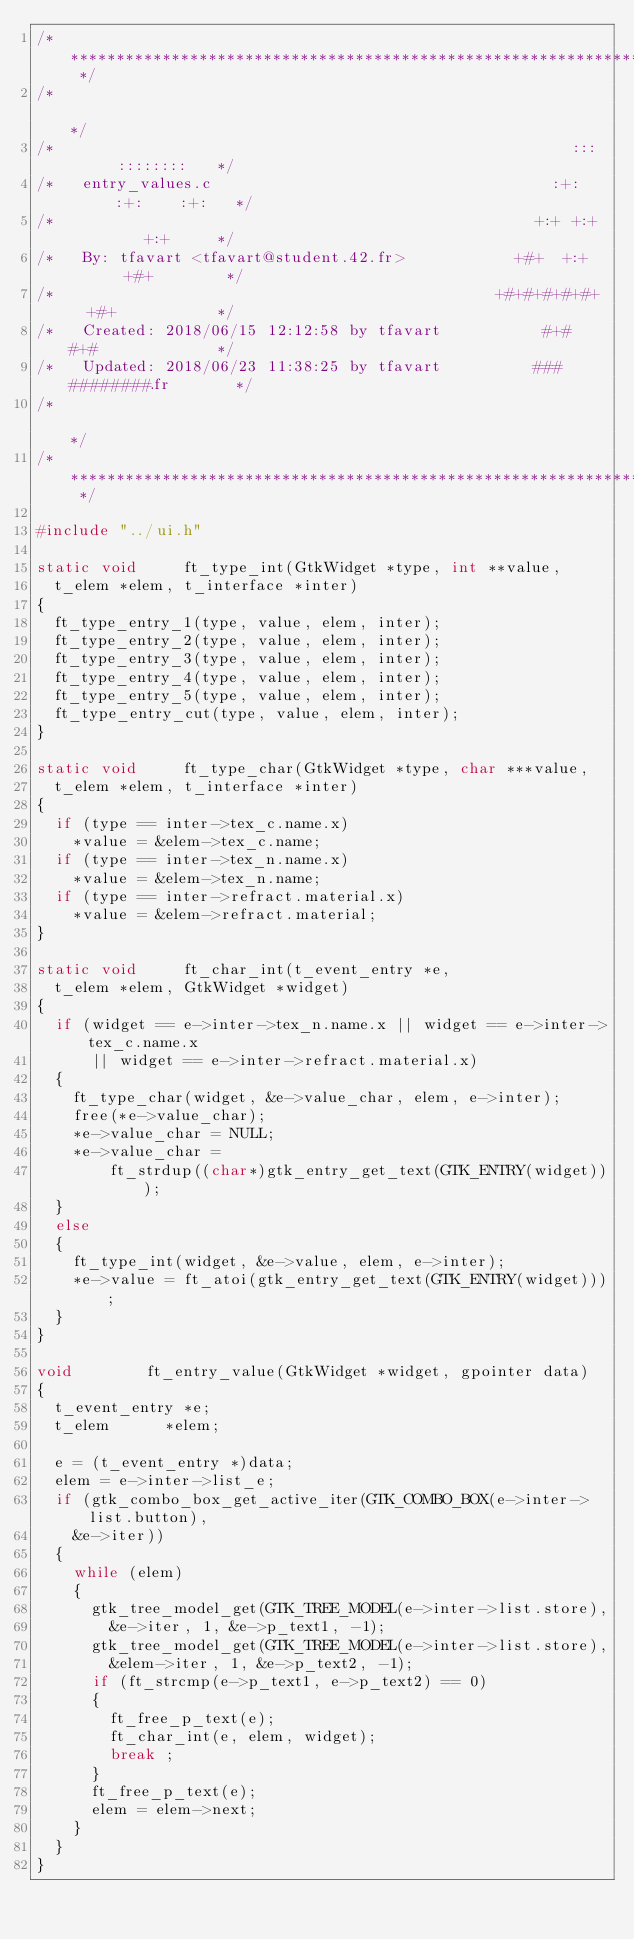<code> <loc_0><loc_0><loc_500><loc_500><_C_>/* ************************************************************************** */
/*                                                                            */
/*                                                        :::      ::::::::   */
/*   entry_values.c                                     :+:      :+:    :+:   */
/*                                                    +:+ +:+         +:+     */
/*   By: tfavart <tfavart@student.42.fr>            +#+  +:+       +#+        */
/*                                                +#+#+#+#+#+   +#+           */
/*   Created: 2018/06/15 12:12:58 by tfavart           #+#    #+#             */
/*   Updated: 2018/06/23 11:38:25 by tfavart          ###   ########.fr       */
/*                                                                            */
/* ************************************************************************** */

#include "../ui.h"

static void			ft_type_int(GtkWidget *type, int **value,
	t_elem *elem, t_interface *inter)
{
	ft_type_entry_1(type, value, elem, inter);
	ft_type_entry_2(type, value, elem, inter);
	ft_type_entry_3(type, value, elem, inter);
	ft_type_entry_4(type, value, elem, inter);
	ft_type_entry_5(type, value, elem, inter);
	ft_type_entry_cut(type, value, elem, inter);
}

static void			ft_type_char(GtkWidget *type, char ***value,
	t_elem *elem, t_interface *inter)
{
	if (type == inter->tex_c.name.x)
		*value = &elem->tex_c.name;
	if (type == inter->tex_n.name.x)
		*value = &elem->tex_n.name;
	if (type == inter->refract.material.x)
		*value = &elem->refract.material;
}

static void			ft_char_int(t_event_entry *e,
	t_elem *elem, GtkWidget *widget)
{
	if (widget == e->inter->tex_n.name.x || widget == e->inter->tex_c.name.x
			|| widget == e->inter->refract.material.x)
	{
		ft_type_char(widget, &e->value_char, elem, e->inter);
		free(*e->value_char);
		*e->value_char = NULL;
		*e->value_char =
				ft_strdup((char*)gtk_entry_get_text(GTK_ENTRY(widget)));
	}
	else
	{
		ft_type_int(widget, &e->value, elem, e->inter);
		*e->value = ft_atoi(gtk_entry_get_text(GTK_ENTRY(widget)));
	}
}

void				ft_entry_value(GtkWidget *widget, gpointer data)
{
	t_event_entry	*e;
	t_elem			*elem;

	e = (t_event_entry *)data;
	elem = e->inter->list_e;
	if (gtk_combo_box_get_active_iter(GTK_COMBO_BOX(e->inter->list.button),
		&e->iter))
	{
		while (elem)
		{
			gtk_tree_model_get(GTK_TREE_MODEL(e->inter->list.store),
				&e->iter, 1, &e->p_text1, -1);
			gtk_tree_model_get(GTK_TREE_MODEL(e->inter->list.store),
				&elem->iter, 1, &e->p_text2, -1);
			if (ft_strcmp(e->p_text1, e->p_text2) == 0)
			{
				ft_free_p_text(e);
				ft_char_int(e, elem, widget);
				break ;
			}
			ft_free_p_text(e);
			elem = elem->next;
		}
	}
}
</code> 